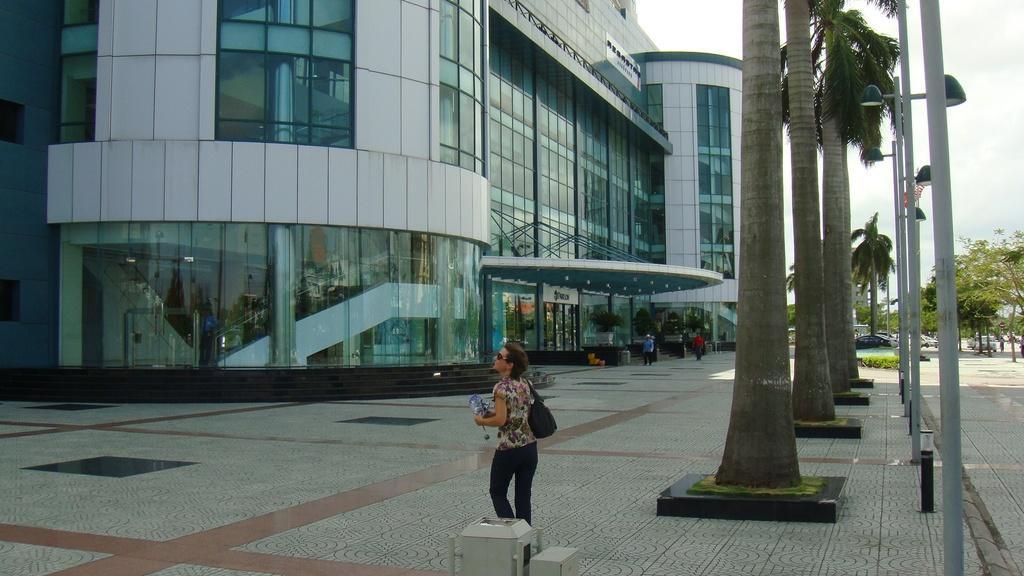Can you describe this image briefly? In this image, we can see a woman is wearing a bag and holding some object. At the bottom, we can see platform and some box. On the right side, we can see the tree trunks, trees, plants, vehicles, walkway and sky. Background there is a building with walls and glass. Through the glass we can see the inside view. Here there is a railing. 